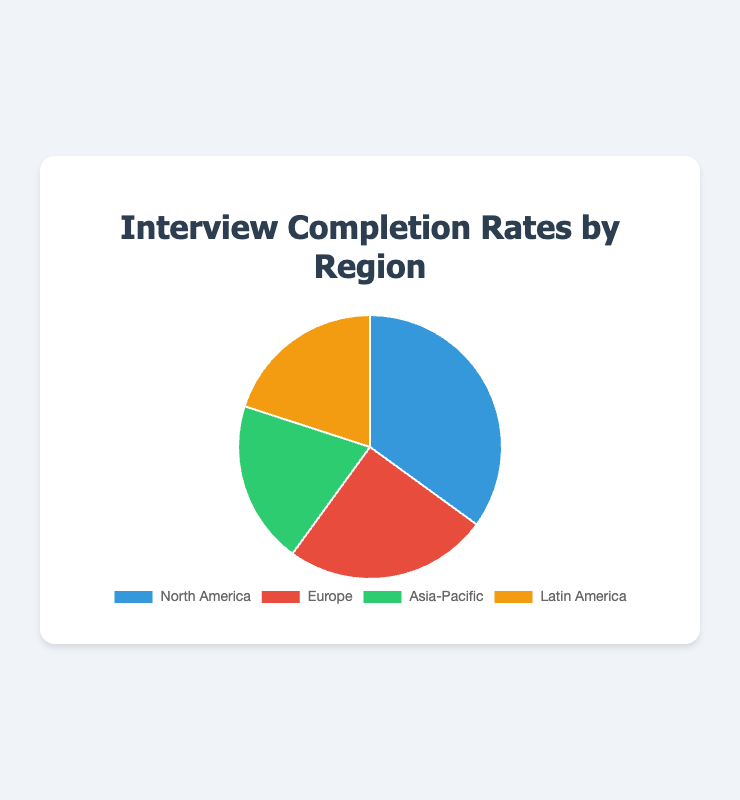Which region has the highest interview completion rate? North America has the highest interview completion rate, which can be seen by observing the largest section of the pie chart.
Answer: North America Which two regions have equal interview completion rates? By looking at the pie chart, we can observe that Asia-Pacific and Latin America have the same size segments, indicating equal completion rates.
Answer: Asia-Pacific and Latin America By how much percent does the interview completion rate of North America exceed that of Europe? North America's completion rate is 35%, while Europe's is 25%. The difference is calculated as 35% - 25%.
Answer: 10% What's the combined interview completion rate of Asia-Pacific and Latin America? Both Asia-Pacific and Latin America have a completion rate of 20%. The combined rate is 20% + 20%.
Answer: 40% Which region has the second-largest interview completion rate? The second largest section of the pie chart belongs to Europe with a 25% interview completion rate.
Answer: Europe What is the difference in interview completion rates between the region with the highest and the lowest rates? The highest rate is North America with 35%, and the lowest rates are tied at 20% for Asia-Pacific and Latin America. The difference is 35% - 20%.
Answer: 15% What is the average interview completion rate among all regions? Sum all the completion rates (35% + 25% + 20% + 20%) to get 100%. Divide by the number of regions (4).
Answer: 25% Which region has a red-colored segment in the pie chart? The pie chart uses red for Europe, identifiable through the legend or key of the chart.
Answer: Europe 